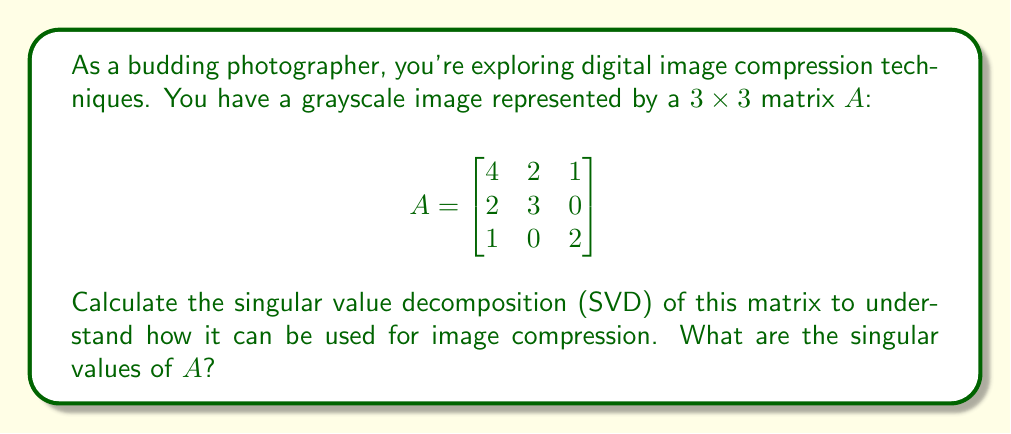Provide a solution to this math problem. To find the singular value decomposition of matrix $A$, we need to follow these steps:

1) Calculate $A^TA$ and $AA^T$:

   $$A^TA = \begin{bmatrix}
   4 & 2 & 1 \\
   2 & 3 & 0 \\
   1 & 0 & 2
   \end{bmatrix}
   \begin{bmatrix}
   4 & 2 & 1 \\
   2 & 3 & 0 \\
   1 & 0 & 2
   \end{bmatrix} = 
   \begin{bmatrix}
   21 & 14 & 6 \\
   14 & 13 & 2 \\
   6 & 2 & 5
   \end{bmatrix}$$

   $$AA^T = \begin{bmatrix}
   4 & 2 & 1 \\
   2 & 3 & 0 \\
   1 & 0 & 2
   \end{bmatrix}
   \begin{bmatrix}
   4 & 2 & 1 \\
   2 & 3 & 0 \\
   1 & 0 & 2
   \end{bmatrix} = 
   \begin{bmatrix}
   21 & 14 & 6 \\
   14 & 13 & 2 \\
   6 & 2 & 5
   \end{bmatrix}$$

2) Find the eigenvalues of $A^TA$ (or $AA^T$, as they are the same in this case):

   Characteristic equation: $det(A^TA - \lambda I) = 0$
   
   $\begin{vmatrix}
   21-\lambda & 14 & 6 \\
   14 & 13-\lambda & 2 \\
   6 & 2 & 5-\lambda
   \end{vmatrix} = 0$

   Solving this equation gives us:
   $\lambda_1 \approx 30.6843$, $\lambda_2 \approx 7.3157$, $\lambda_3 = 1$

3) The singular values are the square roots of these eigenvalues:

   $\sigma_1 = \sqrt{30.6843} \approx 5.5394$
   $\sigma_2 = \sqrt{7.3157} \approx 2.7048$
   $\sigma_3 = \sqrt{1} = 1$

These singular values represent the "importance" of each component in the compressed image. Larger values correspond to more significant features.
Answer: $\sigma_1 \approx 5.5394$, $\sigma_2 \approx 2.7048$, $\sigma_3 = 1$ 